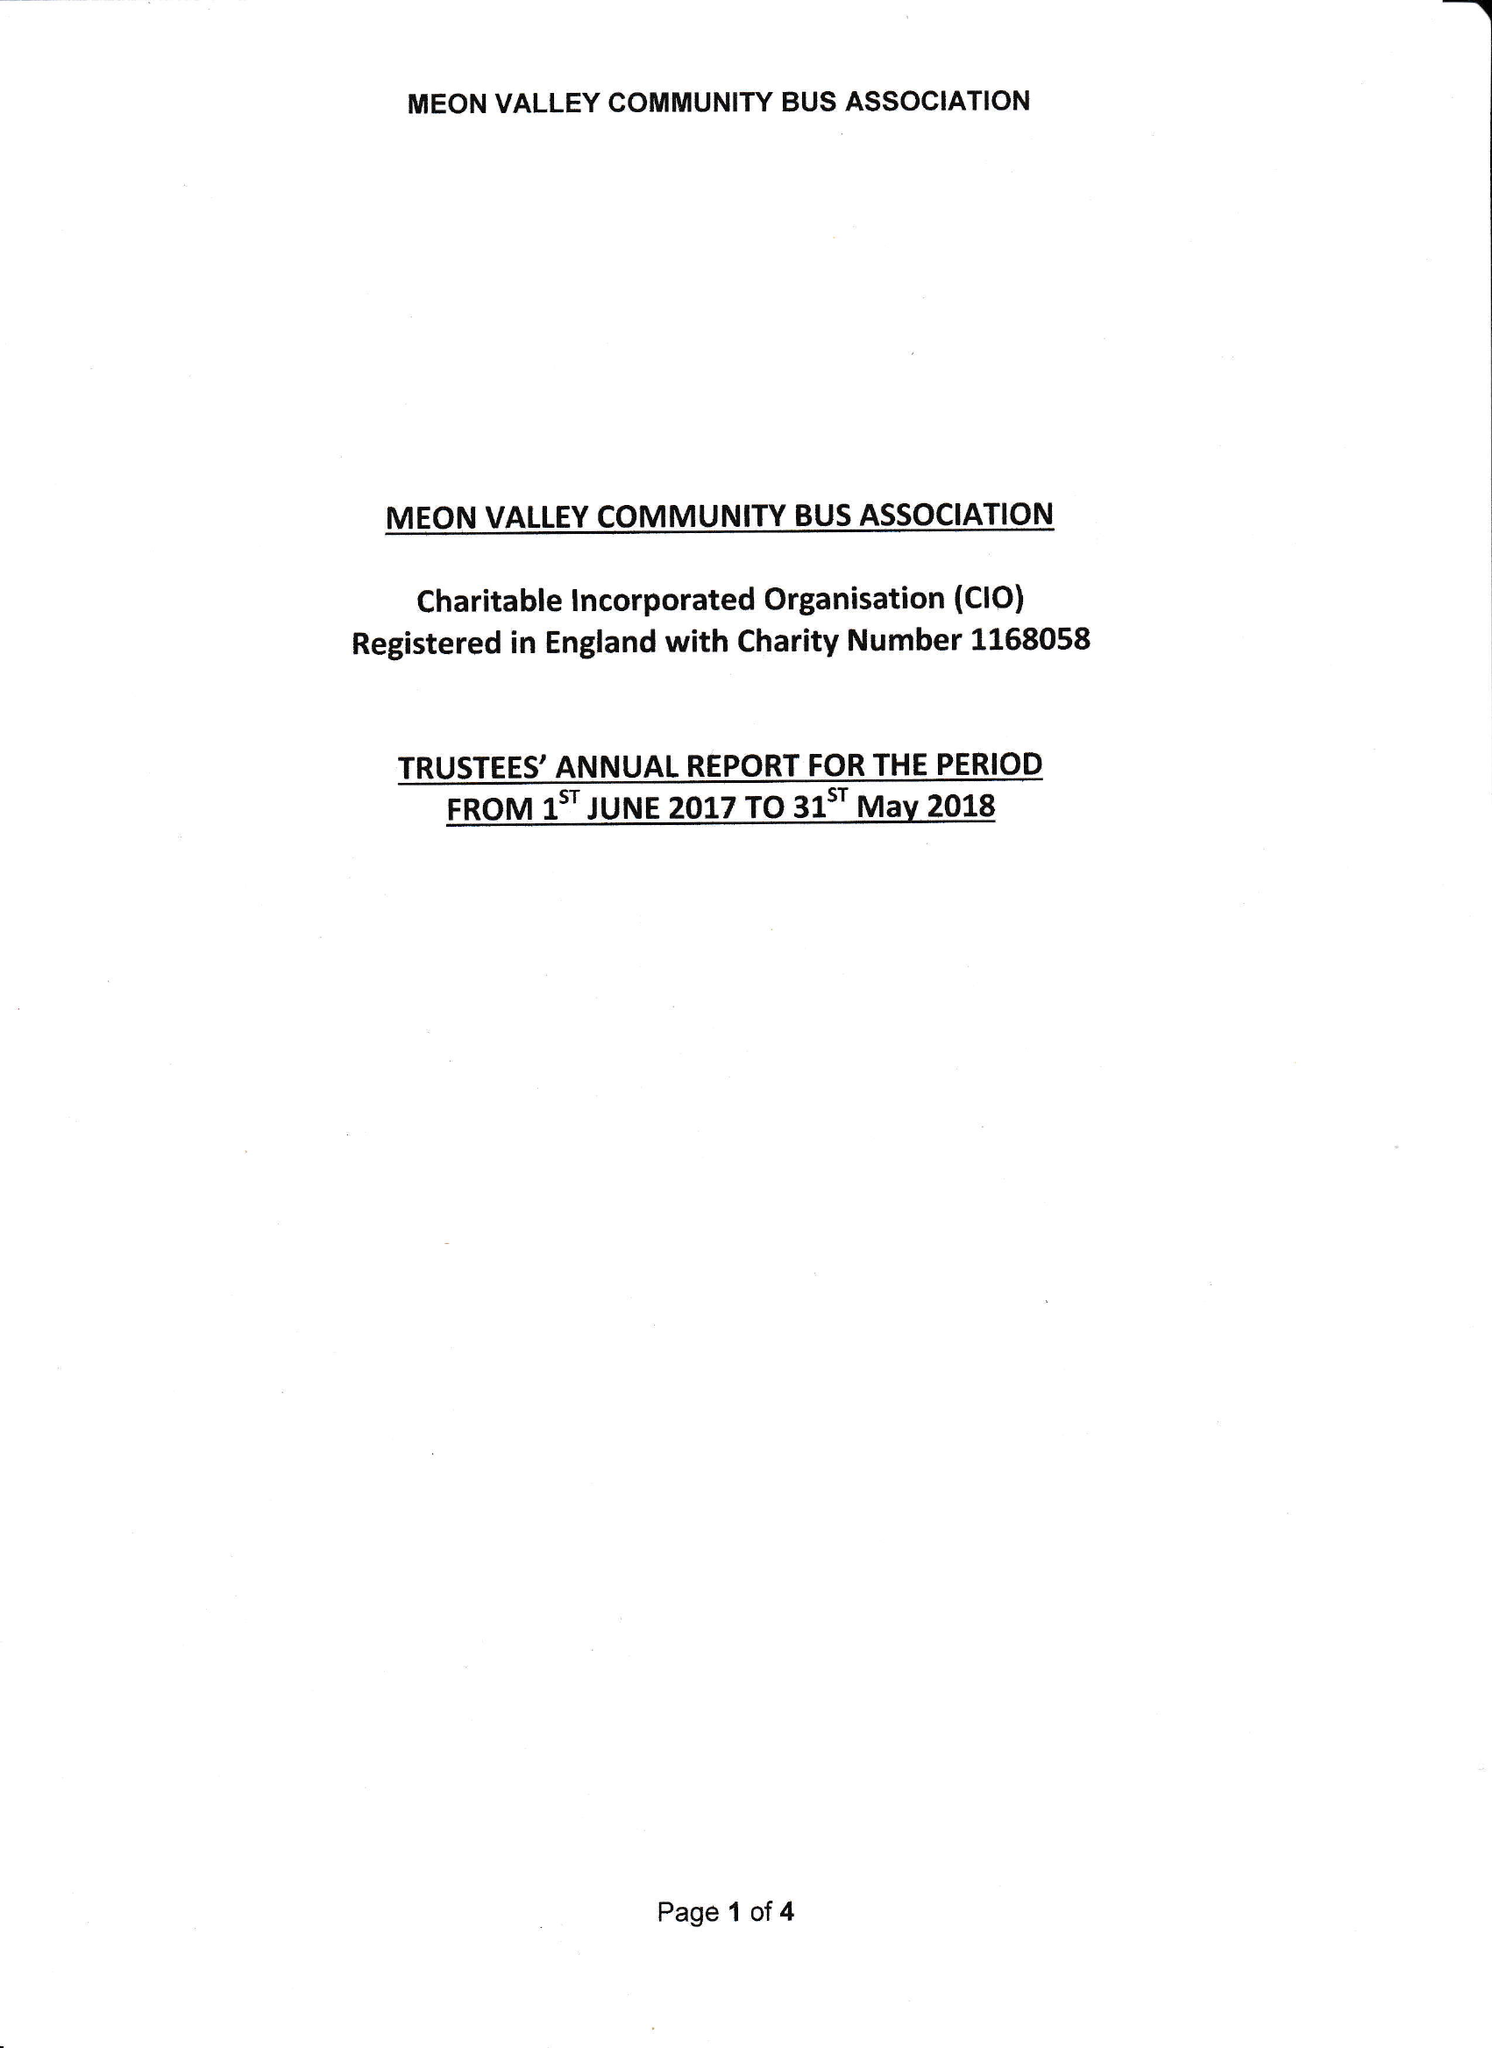What is the value for the charity_name?
Answer the question using a single word or phrase. Meon Valley Community Bus Association 